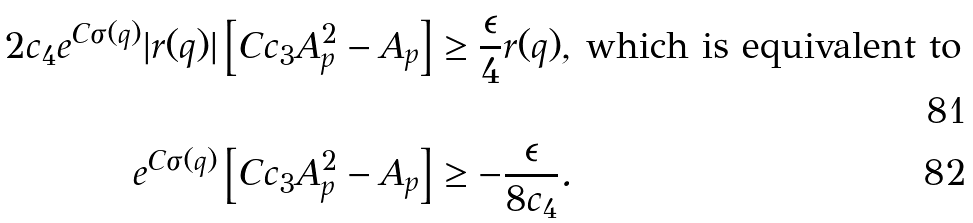<formula> <loc_0><loc_0><loc_500><loc_500>2 c _ { 4 } e ^ { C \sigma ( q ) } | r ( q ) | \left [ C c _ { 3 } A _ { p } ^ { 2 } - A _ { p } \right ] & \geq \frac { \epsilon } { 4 } r ( q ) , \, \text {which is equivalent to} \\ e ^ { C \sigma ( q ) } \left [ C c _ { 3 } A _ { p } ^ { 2 } - A _ { p } \right ] & \geq - \frac { \epsilon } { 8 c _ { 4 } } .</formula> 